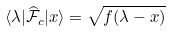<formula> <loc_0><loc_0><loc_500><loc_500>\langle \lambda | \widehat { \mathcal { F } } _ { c } | x \rangle = \sqrt { f ( \lambda - x ) }</formula> 